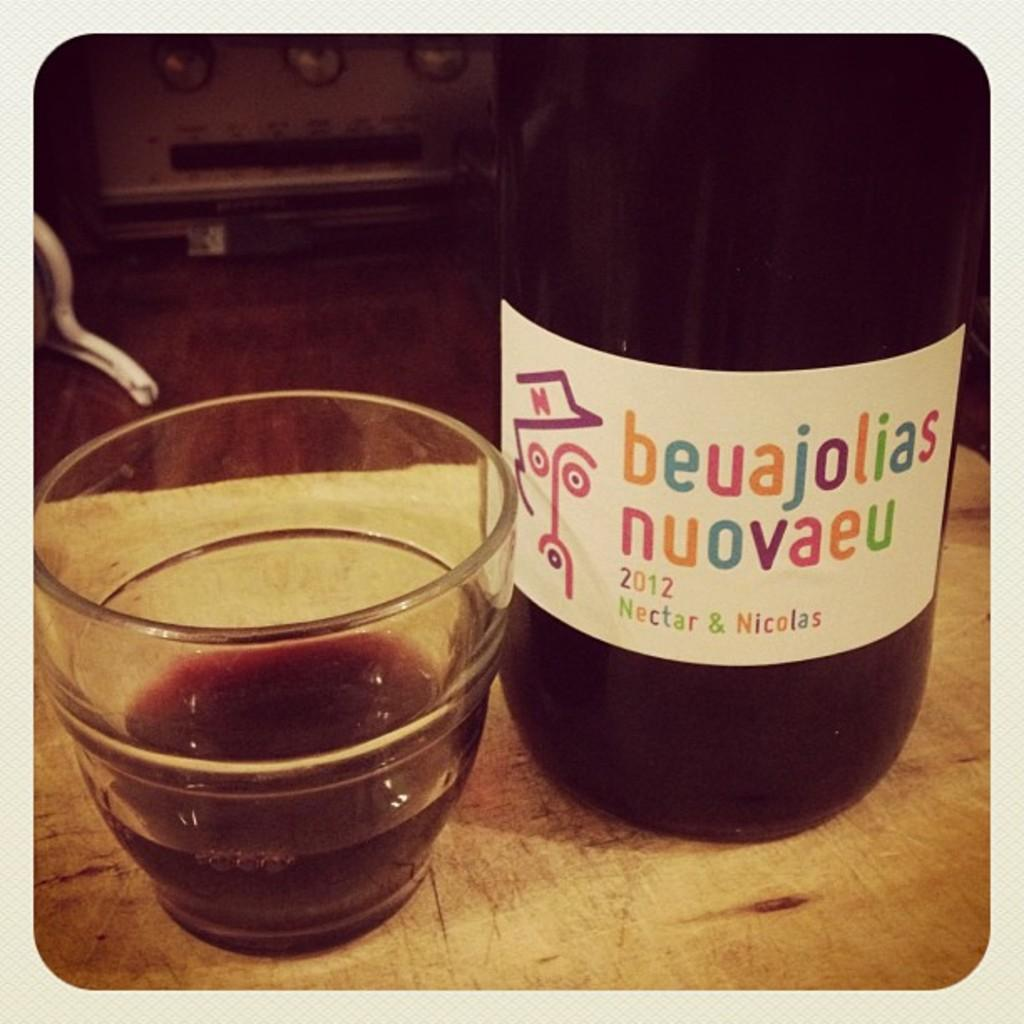<image>
Share a concise interpretation of the image provided. A bottle of beaujolias nuovaeu sits next to a half empty glass 